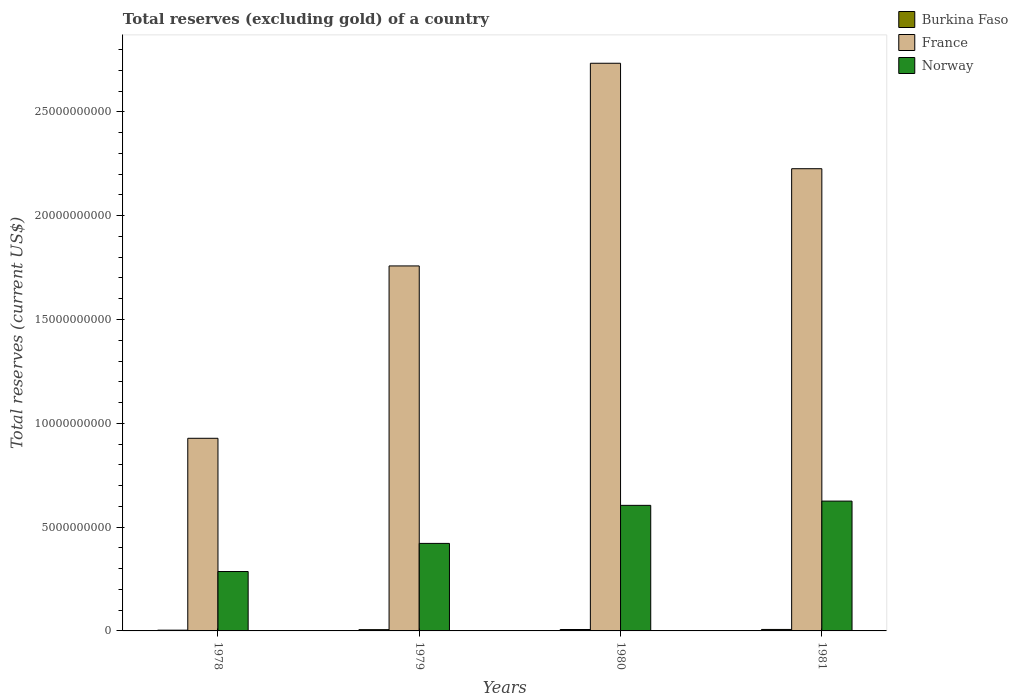How many groups of bars are there?
Provide a short and direct response. 4. Are the number of bars per tick equal to the number of legend labels?
Provide a short and direct response. Yes. How many bars are there on the 4th tick from the left?
Provide a succinct answer. 3. How many bars are there on the 4th tick from the right?
Offer a terse response. 3. What is the total reserves (excluding gold) in Norway in 1980?
Provide a succinct answer. 6.05e+09. Across all years, what is the maximum total reserves (excluding gold) in Norway?
Offer a terse response. 6.25e+09. Across all years, what is the minimum total reserves (excluding gold) in Burkina Faso?
Ensure brevity in your answer.  3.63e+07. In which year was the total reserves (excluding gold) in Norway minimum?
Ensure brevity in your answer.  1978. What is the total total reserves (excluding gold) in France in the graph?
Your answer should be compact. 7.65e+1. What is the difference between the total reserves (excluding gold) in Norway in 1978 and that in 1979?
Offer a terse response. -1.35e+09. What is the difference between the total reserves (excluding gold) in France in 1981 and the total reserves (excluding gold) in Burkina Faso in 1978?
Your answer should be very brief. 2.22e+1. What is the average total reserves (excluding gold) in France per year?
Your answer should be very brief. 1.91e+1. In the year 1980, what is the difference between the total reserves (excluding gold) in Burkina Faso and total reserves (excluding gold) in France?
Ensure brevity in your answer.  -2.73e+1. In how many years, is the total reserves (excluding gold) in Norway greater than 26000000000 US$?
Your answer should be very brief. 0. What is the ratio of the total reserves (excluding gold) in Burkina Faso in 1979 to that in 1980?
Your answer should be very brief. 0.9. Is the total reserves (excluding gold) in Burkina Faso in 1978 less than that in 1980?
Provide a succinct answer. Yes. What is the difference between the highest and the second highest total reserves (excluding gold) in Burkina Faso?
Provide a succinct answer. 2.65e+06. What is the difference between the highest and the lowest total reserves (excluding gold) in Norway?
Your response must be concise. 3.39e+09. In how many years, is the total reserves (excluding gold) in Burkina Faso greater than the average total reserves (excluding gold) in Burkina Faso taken over all years?
Offer a terse response. 3. Is the sum of the total reserves (excluding gold) in Norway in 1980 and 1981 greater than the maximum total reserves (excluding gold) in Burkina Faso across all years?
Ensure brevity in your answer.  Yes. What does the 1st bar from the left in 1979 represents?
Provide a succinct answer. Burkina Faso. What does the 2nd bar from the right in 1979 represents?
Keep it short and to the point. France. Is it the case that in every year, the sum of the total reserves (excluding gold) in Burkina Faso and total reserves (excluding gold) in France is greater than the total reserves (excluding gold) in Norway?
Your answer should be compact. Yes. How many bars are there?
Give a very brief answer. 12. Are all the bars in the graph horizontal?
Your response must be concise. No. What is the difference between two consecutive major ticks on the Y-axis?
Make the answer very short. 5.00e+09. How many legend labels are there?
Offer a very short reply. 3. How are the legend labels stacked?
Ensure brevity in your answer.  Vertical. What is the title of the graph?
Provide a short and direct response. Total reserves (excluding gold) of a country. What is the label or title of the Y-axis?
Provide a succinct answer. Total reserves (current US$). What is the Total reserves (current US$) in Burkina Faso in 1978?
Make the answer very short. 3.63e+07. What is the Total reserves (current US$) in France in 1978?
Keep it short and to the point. 9.28e+09. What is the Total reserves (current US$) in Norway in 1978?
Your response must be concise. 2.86e+09. What is the Total reserves (current US$) in Burkina Faso in 1979?
Your answer should be compact. 6.16e+07. What is the Total reserves (current US$) in France in 1979?
Give a very brief answer. 1.76e+1. What is the Total reserves (current US$) of Norway in 1979?
Provide a short and direct response. 4.22e+09. What is the Total reserves (current US$) in Burkina Faso in 1980?
Give a very brief answer. 6.82e+07. What is the Total reserves (current US$) in France in 1980?
Ensure brevity in your answer.  2.73e+1. What is the Total reserves (current US$) in Norway in 1980?
Keep it short and to the point. 6.05e+09. What is the Total reserves (current US$) of Burkina Faso in 1981?
Offer a very short reply. 7.08e+07. What is the Total reserves (current US$) of France in 1981?
Give a very brief answer. 2.23e+1. What is the Total reserves (current US$) of Norway in 1981?
Provide a succinct answer. 6.25e+09. Across all years, what is the maximum Total reserves (current US$) of Burkina Faso?
Give a very brief answer. 7.08e+07. Across all years, what is the maximum Total reserves (current US$) of France?
Make the answer very short. 2.73e+1. Across all years, what is the maximum Total reserves (current US$) in Norway?
Your answer should be very brief. 6.25e+09. Across all years, what is the minimum Total reserves (current US$) of Burkina Faso?
Provide a short and direct response. 3.63e+07. Across all years, what is the minimum Total reserves (current US$) of France?
Make the answer very short. 9.28e+09. Across all years, what is the minimum Total reserves (current US$) of Norway?
Your answer should be very brief. 2.86e+09. What is the total Total reserves (current US$) of Burkina Faso in the graph?
Offer a terse response. 2.37e+08. What is the total Total reserves (current US$) in France in the graph?
Offer a terse response. 7.65e+1. What is the total Total reserves (current US$) in Norway in the graph?
Your answer should be very brief. 1.94e+1. What is the difference between the Total reserves (current US$) in Burkina Faso in 1978 and that in 1979?
Your response must be concise. -2.53e+07. What is the difference between the Total reserves (current US$) in France in 1978 and that in 1979?
Your response must be concise. -8.30e+09. What is the difference between the Total reserves (current US$) in Norway in 1978 and that in 1979?
Offer a terse response. -1.35e+09. What is the difference between the Total reserves (current US$) of Burkina Faso in 1978 and that in 1980?
Give a very brief answer. -3.19e+07. What is the difference between the Total reserves (current US$) of France in 1978 and that in 1980?
Give a very brief answer. -1.81e+1. What is the difference between the Total reserves (current US$) in Norway in 1978 and that in 1980?
Provide a succinct answer. -3.19e+09. What is the difference between the Total reserves (current US$) in Burkina Faso in 1978 and that in 1981?
Make the answer very short. -3.45e+07. What is the difference between the Total reserves (current US$) of France in 1978 and that in 1981?
Give a very brief answer. -1.30e+1. What is the difference between the Total reserves (current US$) in Norway in 1978 and that in 1981?
Your answer should be very brief. -3.39e+09. What is the difference between the Total reserves (current US$) in Burkina Faso in 1979 and that in 1980?
Your answer should be compact. -6.61e+06. What is the difference between the Total reserves (current US$) in France in 1979 and that in 1980?
Offer a very short reply. -9.76e+09. What is the difference between the Total reserves (current US$) in Norway in 1979 and that in 1980?
Your answer should be very brief. -1.83e+09. What is the difference between the Total reserves (current US$) in Burkina Faso in 1979 and that in 1981?
Provide a short and direct response. -9.26e+06. What is the difference between the Total reserves (current US$) of France in 1979 and that in 1981?
Keep it short and to the point. -4.68e+09. What is the difference between the Total reserves (current US$) of Norway in 1979 and that in 1981?
Your answer should be very brief. -2.04e+09. What is the difference between the Total reserves (current US$) in Burkina Faso in 1980 and that in 1981?
Offer a very short reply. -2.65e+06. What is the difference between the Total reserves (current US$) of France in 1980 and that in 1981?
Give a very brief answer. 5.08e+09. What is the difference between the Total reserves (current US$) of Norway in 1980 and that in 1981?
Provide a short and direct response. -2.05e+08. What is the difference between the Total reserves (current US$) in Burkina Faso in 1978 and the Total reserves (current US$) in France in 1979?
Provide a short and direct response. -1.75e+1. What is the difference between the Total reserves (current US$) in Burkina Faso in 1978 and the Total reserves (current US$) in Norway in 1979?
Offer a terse response. -4.18e+09. What is the difference between the Total reserves (current US$) in France in 1978 and the Total reserves (current US$) in Norway in 1979?
Your response must be concise. 5.06e+09. What is the difference between the Total reserves (current US$) of Burkina Faso in 1978 and the Total reserves (current US$) of France in 1980?
Your answer should be very brief. -2.73e+1. What is the difference between the Total reserves (current US$) in Burkina Faso in 1978 and the Total reserves (current US$) in Norway in 1980?
Ensure brevity in your answer.  -6.01e+09. What is the difference between the Total reserves (current US$) of France in 1978 and the Total reserves (current US$) of Norway in 1980?
Your answer should be compact. 3.23e+09. What is the difference between the Total reserves (current US$) of Burkina Faso in 1978 and the Total reserves (current US$) of France in 1981?
Your answer should be compact. -2.22e+1. What is the difference between the Total reserves (current US$) of Burkina Faso in 1978 and the Total reserves (current US$) of Norway in 1981?
Make the answer very short. -6.22e+09. What is the difference between the Total reserves (current US$) of France in 1978 and the Total reserves (current US$) of Norway in 1981?
Your answer should be compact. 3.03e+09. What is the difference between the Total reserves (current US$) in Burkina Faso in 1979 and the Total reserves (current US$) in France in 1980?
Provide a succinct answer. -2.73e+1. What is the difference between the Total reserves (current US$) of Burkina Faso in 1979 and the Total reserves (current US$) of Norway in 1980?
Your answer should be compact. -5.99e+09. What is the difference between the Total reserves (current US$) of France in 1979 and the Total reserves (current US$) of Norway in 1980?
Provide a short and direct response. 1.15e+1. What is the difference between the Total reserves (current US$) of Burkina Faso in 1979 and the Total reserves (current US$) of France in 1981?
Offer a very short reply. -2.22e+1. What is the difference between the Total reserves (current US$) in Burkina Faso in 1979 and the Total reserves (current US$) in Norway in 1981?
Give a very brief answer. -6.19e+09. What is the difference between the Total reserves (current US$) in France in 1979 and the Total reserves (current US$) in Norway in 1981?
Make the answer very short. 1.13e+1. What is the difference between the Total reserves (current US$) of Burkina Faso in 1980 and the Total reserves (current US$) of France in 1981?
Make the answer very short. -2.22e+1. What is the difference between the Total reserves (current US$) of Burkina Faso in 1980 and the Total reserves (current US$) of Norway in 1981?
Keep it short and to the point. -6.18e+09. What is the difference between the Total reserves (current US$) in France in 1980 and the Total reserves (current US$) in Norway in 1981?
Your answer should be compact. 2.11e+1. What is the average Total reserves (current US$) of Burkina Faso per year?
Offer a very short reply. 5.92e+07. What is the average Total reserves (current US$) in France per year?
Provide a succinct answer. 1.91e+1. What is the average Total reserves (current US$) of Norway per year?
Your answer should be very brief. 4.84e+09. In the year 1978, what is the difference between the Total reserves (current US$) in Burkina Faso and Total reserves (current US$) in France?
Provide a succinct answer. -9.24e+09. In the year 1978, what is the difference between the Total reserves (current US$) of Burkina Faso and Total reserves (current US$) of Norway?
Your answer should be very brief. -2.82e+09. In the year 1978, what is the difference between the Total reserves (current US$) of France and Total reserves (current US$) of Norway?
Give a very brief answer. 6.42e+09. In the year 1979, what is the difference between the Total reserves (current US$) of Burkina Faso and Total reserves (current US$) of France?
Offer a very short reply. -1.75e+1. In the year 1979, what is the difference between the Total reserves (current US$) in Burkina Faso and Total reserves (current US$) in Norway?
Your answer should be compact. -4.15e+09. In the year 1979, what is the difference between the Total reserves (current US$) of France and Total reserves (current US$) of Norway?
Provide a short and direct response. 1.34e+1. In the year 1980, what is the difference between the Total reserves (current US$) of Burkina Faso and Total reserves (current US$) of France?
Make the answer very short. -2.73e+1. In the year 1980, what is the difference between the Total reserves (current US$) of Burkina Faso and Total reserves (current US$) of Norway?
Your answer should be very brief. -5.98e+09. In the year 1980, what is the difference between the Total reserves (current US$) in France and Total reserves (current US$) in Norway?
Offer a very short reply. 2.13e+1. In the year 1981, what is the difference between the Total reserves (current US$) of Burkina Faso and Total reserves (current US$) of France?
Make the answer very short. -2.22e+1. In the year 1981, what is the difference between the Total reserves (current US$) in Burkina Faso and Total reserves (current US$) in Norway?
Offer a terse response. -6.18e+09. In the year 1981, what is the difference between the Total reserves (current US$) in France and Total reserves (current US$) in Norway?
Ensure brevity in your answer.  1.60e+1. What is the ratio of the Total reserves (current US$) in Burkina Faso in 1978 to that in 1979?
Your response must be concise. 0.59. What is the ratio of the Total reserves (current US$) of France in 1978 to that in 1979?
Ensure brevity in your answer.  0.53. What is the ratio of the Total reserves (current US$) in Norway in 1978 to that in 1979?
Your answer should be compact. 0.68. What is the ratio of the Total reserves (current US$) in Burkina Faso in 1978 to that in 1980?
Keep it short and to the point. 0.53. What is the ratio of the Total reserves (current US$) in France in 1978 to that in 1980?
Your answer should be very brief. 0.34. What is the ratio of the Total reserves (current US$) in Norway in 1978 to that in 1980?
Provide a short and direct response. 0.47. What is the ratio of the Total reserves (current US$) of Burkina Faso in 1978 to that in 1981?
Keep it short and to the point. 0.51. What is the ratio of the Total reserves (current US$) in France in 1978 to that in 1981?
Offer a terse response. 0.42. What is the ratio of the Total reserves (current US$) in Norway in 1978 to that in 1981?
Offer a terse response. 0.46. What is the ratio of the Total reserves (current US$) in Burkina Faso in 1979 to that in 1980?
Keep it short and to the point. 0.9. What is the ratio of the Total reserves (current US$) in France in 1979 to that in 1980?
Your answer should be very brief. 0.64. What is the ratio of the Total reserves (current US$) of Norway in 1979 to that in 1980?
Your answer should be very brief. 0.7. What is the ratio of the Total reserves (current US$) of Burkina Faso in 1979 to that in 1981?
Provide a short and direct response. 0.87. What is the ratio of the Total reserves (current US$) of France in 1979 to that in 1981?
Offer a very short reply. 0.79. What is the ratio of the Total reserves (current US$) in Norway in 1979 to that in 1981?
Your response must be concise. 0.67. What is the ratio of the Total reserves (current US$) of Burkina Faso in 1980 to that in 1981?
Make the answer very short. 0.96. What is the ratio of the Total reserves (current US$) of France in 1980 to that in 1981?
Ensure brevity in your answer.  1.23. What is the ratio of the Total reserves (current US$) in Norway in 1980 to that in 1981?
Your answer should be very brief. 0.97. What is the difference between the highest and the second highest Total reserves (current US$) of Burkina Faso?
Provide a short and direct response. 2.65e+06. What is the difference between the highest and the second highest Total reserves (current US$) in France?
Give a very brief answer. 5.08e+09. What is the difference between the highest and the second highest Total reserves (current US$) in Norway?
Provide a short and direct response. 2.05e+08. What is the difference between the highest and the lowest Total reserves (current US$) in Burkina Faso?
Your answer should be compact. 3.45e+07. What is the difference between the highest and the lowest Total reserves (current US$) of France?
Offer a terse response. 1.81e+1. What is the difference between the highest and the lowest Total reserves (current US$) of Norway?
Your response must be concise. 3.39e+09. 